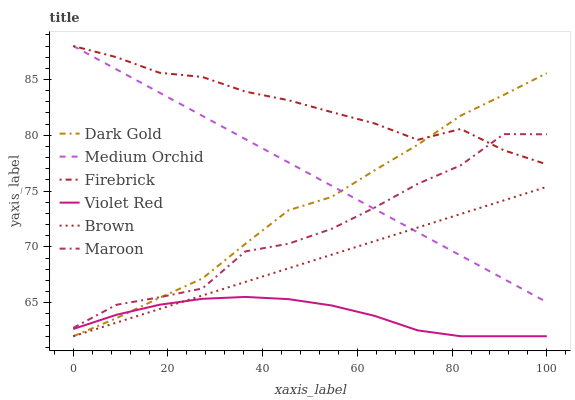Does Dark Gold have the minimum area under the curve?
Answer yes or no. No. Does Dark Gold have the maximum area under the curve?
Answer yes or no. No. Is Violet Red the smoothest?
Answer yes or no. No. Is Violet Red the roughest?
Answer yes or no. No. Does Firebrick have the lowest value?
Answer yes or no. No. Does Dark Gold have the highest value?
Answer yes or no. No. Is Violet Red less than Medium Orchid?
Answer yes or no. Yes. Is Medium Orchid greater than Violet Red?
Answer yes or no. Yes. Does Violet Red intersect Medium Orchid?
Answer yes or no. No. 